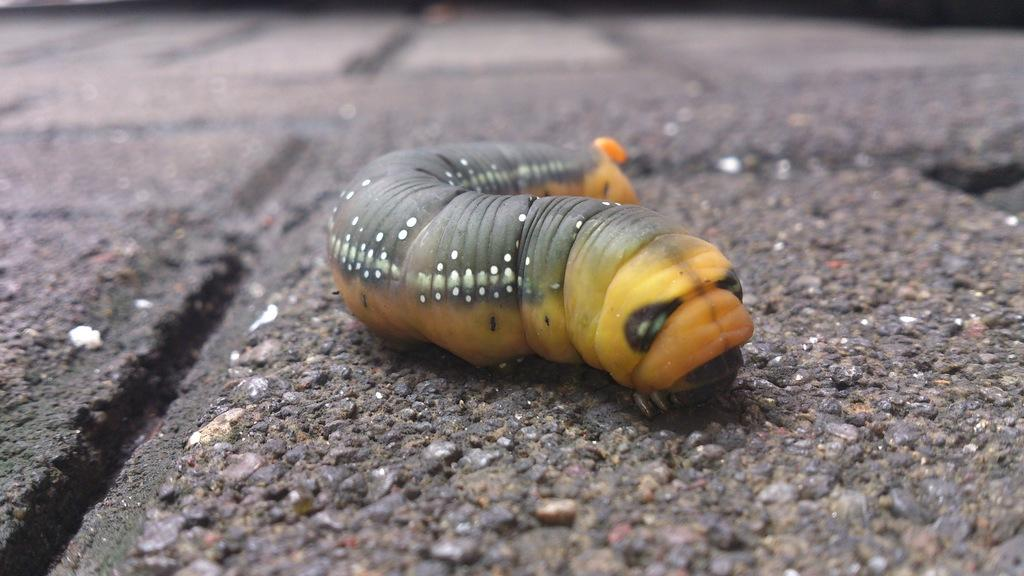What type of creature is in the image? There is an insect in the image. Can you describe the colors of the insect? The insect has black, white, orange, and yellow colors. Where is the insect located in the image? The insect is on a surface. What can be observed about the background of the image? The background of the image is blurred. Are there any snakes visible in the image? There are no snakes present in the image; it features an insect on a surface. 